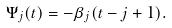Convert formula to latex. <formula><loc_0><loc_0><loc_500><loc_500>\Psi _ { j } ( t ) = - \beta _ { j } ( t - j + 1 ) .</formula> 